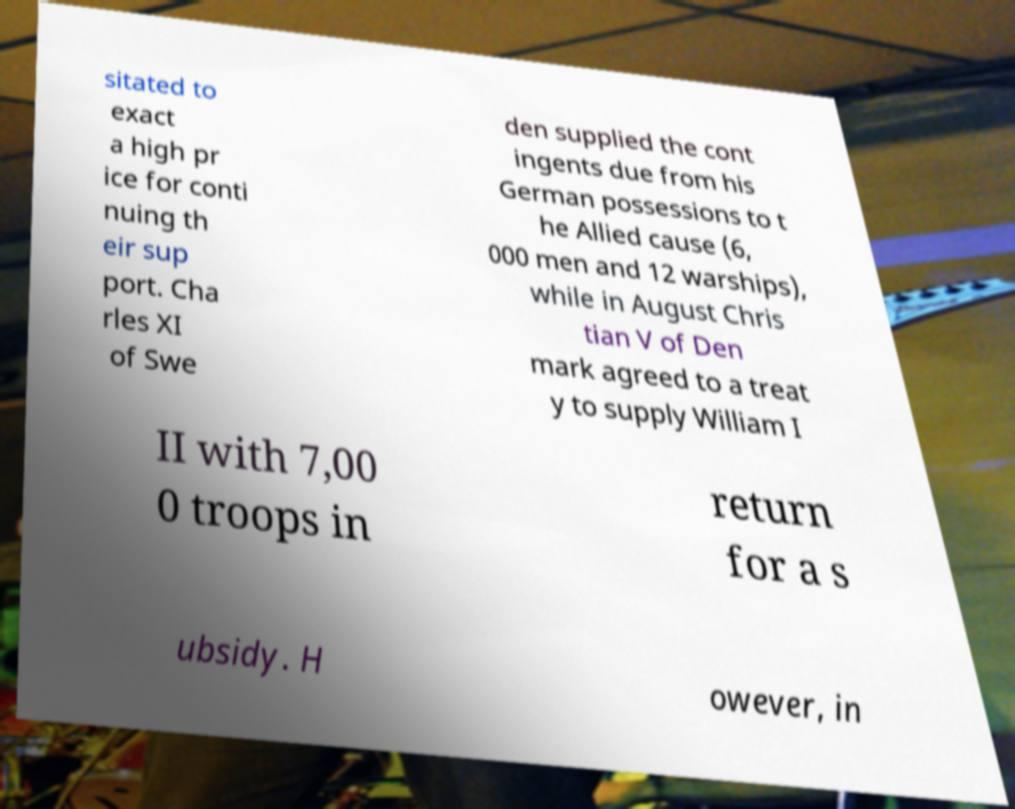Please read and relay the text visible in this image. What does it say? sitated to exact a high pr ice for conti nuing th eir sup port. Cha rles XI of Swe den supplied the cont ingents due from his German possessions to t he Allied cause (6, 000 men and 12 warships), while in August Chris tian V of Den mark agreed to a treat y to supply William I II with 7,00 0 troops in return for a s ubsidy. H owever, in 